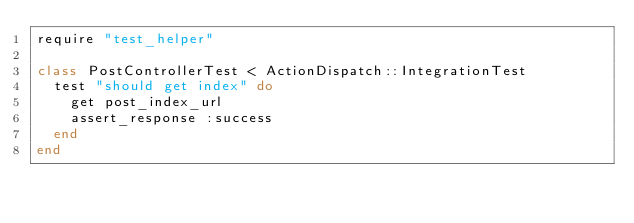Convert code to text. <code><loc_0><loc_0><loc_500><loc_500><_Ruby_>require "test_helper"

class PostControllerTest < ActionDispatch::IntegrationTest
  test "should get index" do
    get post_index_url
    assert_response :success
  end
end
</code> 